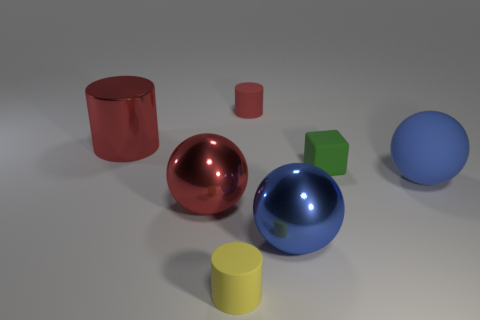How many small matte cylinders are the same color as the big shiny cylinder?
Give a very brief answer. 1. Are there more large red metallic balls right of the green object than red things that are to the left of the big red metal ball?
Provide a short and direct response. No. There is a green object that is the same size as the red matte cylinder; what is its material?
Your answer should be very brief. Rubber. What number of small things are either red things or cylinders?
Keep it short and to the point. 2. Is the large matte object the same shape as the small green matte thing?
Provide a short and direct response. No. How many things are in front of the green matte thing and on the left side of the tiny yellow thing?
Provide a succinct answer. 1. Is there any other thing that has the same color as the small matte cube?
Offer a terse response. No. What shape is the big red object that is made of the same material as the large red cylinder?
Your response must be concise. Sphere. Does the blue shiny object have the same size as the metal cylinder?
Provide a short and direct response. Yes. Are the big blue sphere left of the block and the small green object made of the same material?
Provide a short and direct response. No. 